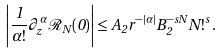<formula> <loc_0><loc_0><loc_500><loc_500>\left | \frac { 1 } { \alpha ! } \partial _ { z } ^ { \alpha } \mathcal { R } _ { N } ( 0 ) \right | \leq A _ { 2 } r ^ { - | \alpha | } B _ { 2 } ^ { - s N } N ! ^ { s } \, .</formula> 